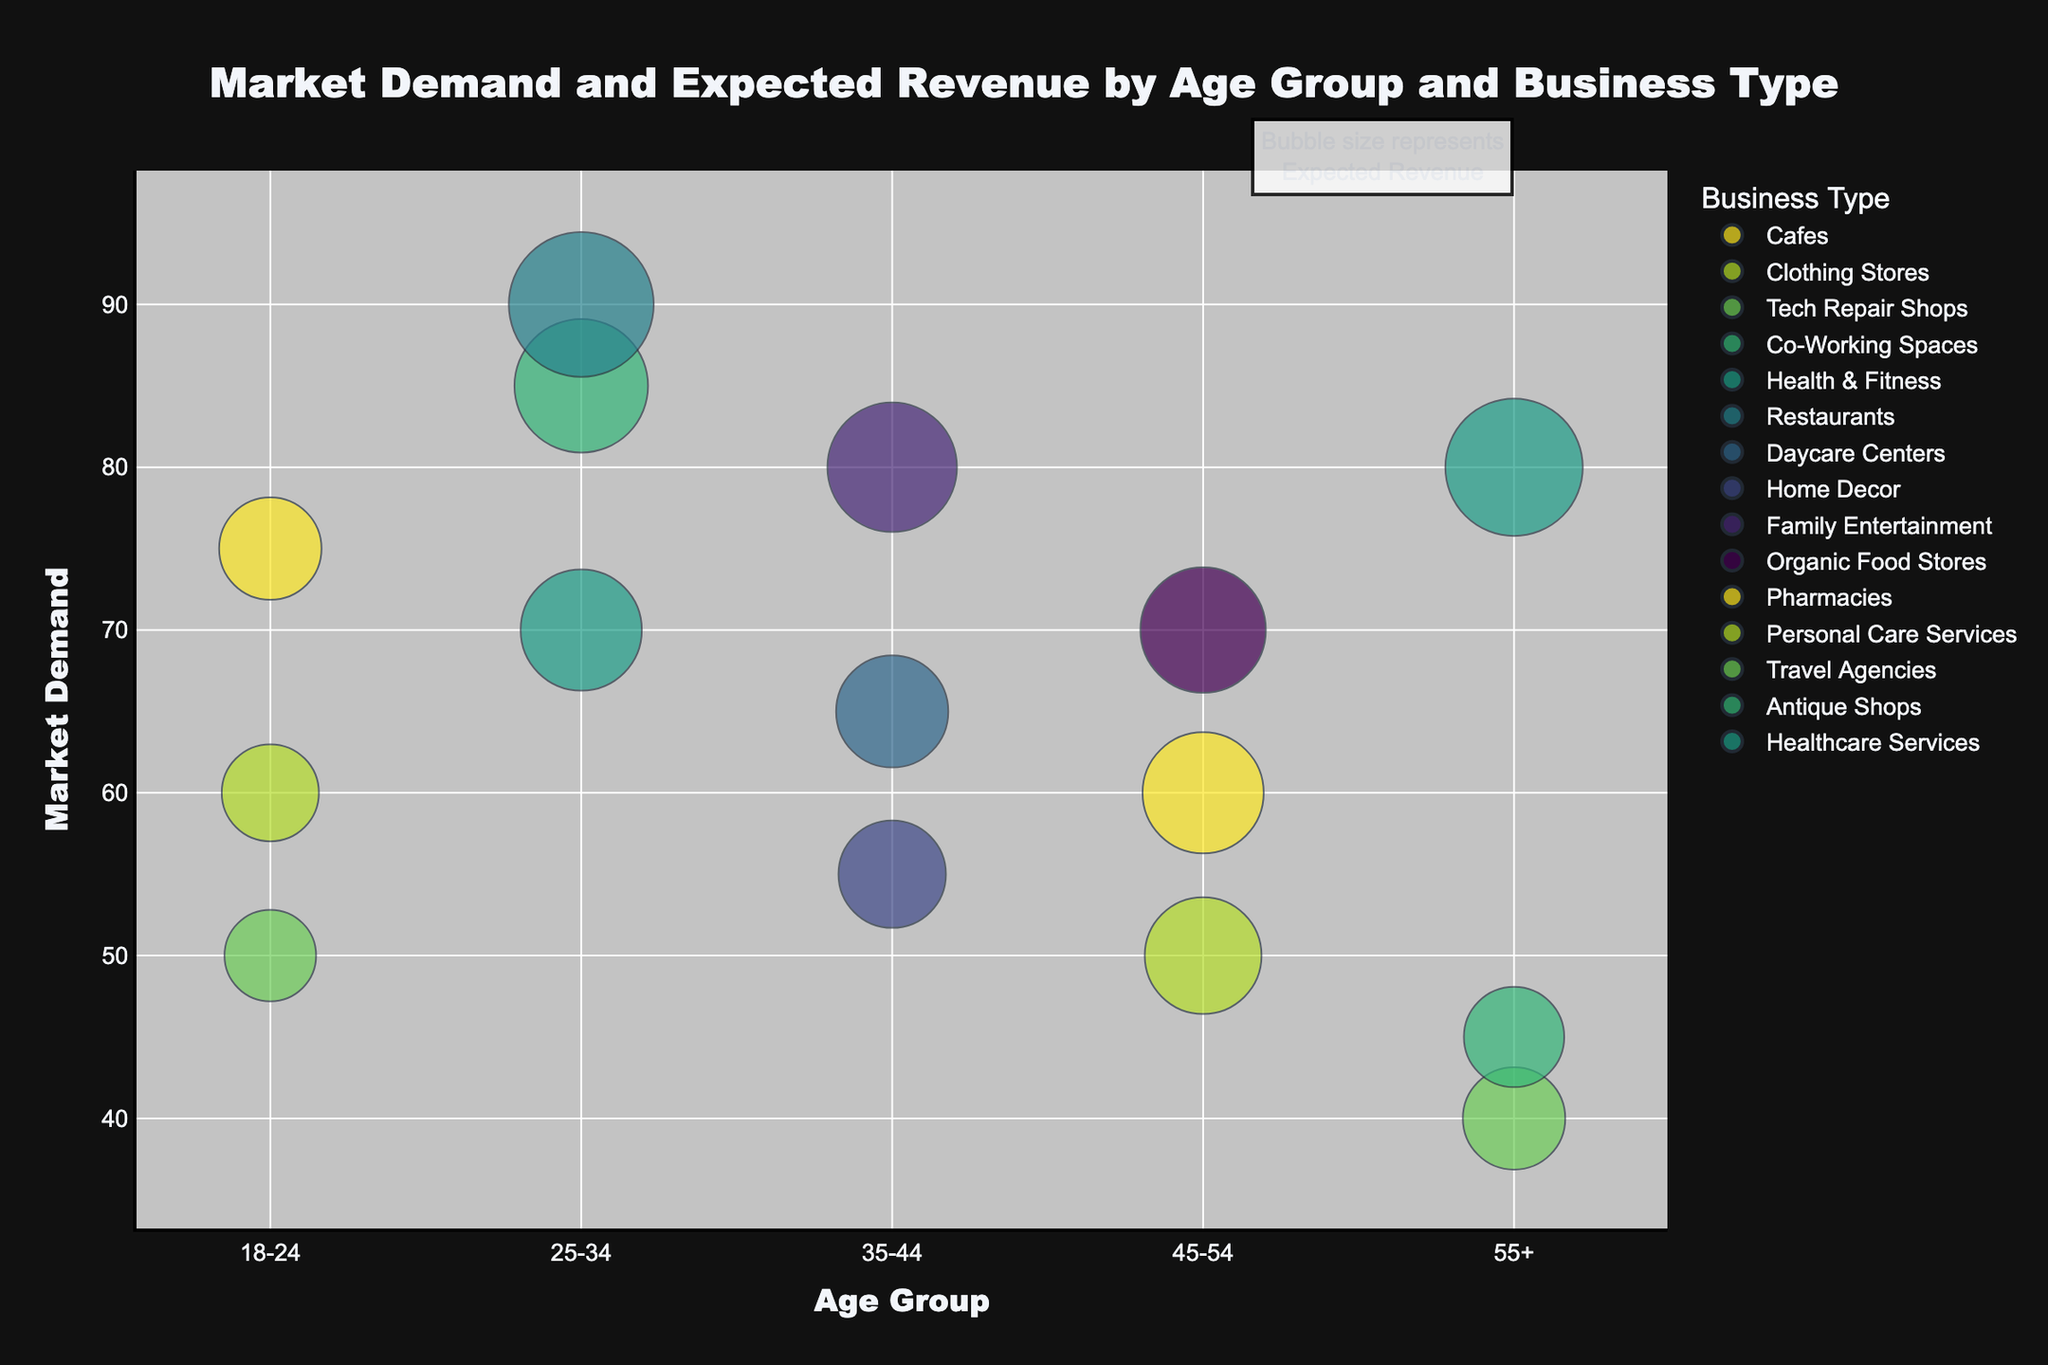What is the title of the figure? The title of the figure is usually displayed prominently at the top. In this case, it reads "Market Demand and Expected Revenue by Age Group and Business Type."
Answer: Market Demand and Expected Revenue by Age Group and Business Type Which age group has the highest market demand for any business type? By observing the height on the y-axis (Market Demand), the highest point corresponds to the age group 25-34 with the business type "Restaurants" having a market demand of 90.
Answer: 25-34 What is the business type with the lowest expected revenue? Look for the smallest bubble size in the figure. The smallest bubble corresponds to the "Antique Shops" in the age group 55+ with an expected revenue of $48,000.
Answer: Antique Shops How does market demand for "Cafes" compare between the 18-24 and 25-34 age groups? The "Cafes" business type appears only in the 18-24 age group with a market demand of 75. There is no "Cafes" data point for the 25-34 age group to compare with.
Answer: Only in 18-24 with demand of 75 Which business type has the highest expected revenue and what is that revenue? Examine the bubble sizes; the largest bubble is "Restaurants" in the 25-34 age group with an expected revenue of $100,000.
Answer: Restaurants, $100,000 What's the difference in market demand between "Pharmacies" and "Personal Care Services" in the 45-54 age group? The market demand for "Pharmacies" is 60, and for "Personal Care Services" it is 50. The difference is 60 - 50 = 10.
Answer: 10 How many different business types are represented in the age group 18-24? By counting the distinct bubbles in the 18-24 age group on the x-axis, there are 3 distinct business types: "Cafes," "Clothing Stores," and "Tech Repair Shops."
Answer: 3 Which age group shows the highest number of different business types? Count the distinct bubbles for each age group on the x-axis. The 25-34 age group has 3 distinct business types: "Co-Working Spaces," "Health & Fitness," and "Restaurants."
Answer: 25-34 For the age group 55+, which business type has the highest market demand? Identify the highest bubble on the y-axis in the 55+ category. "Healthcare Services" has the highest market demand with a value of 80.
Answer: Healthcare Services 